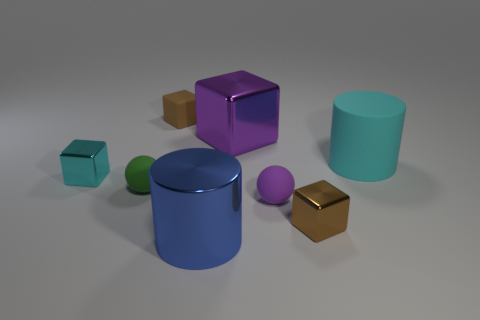There is a metal object that is the same color as the big matte cylinder; what is its shape?
Your answer should be compact. Cube. What number of small purple balls have the same material as the small green object?
Provide a succinct answer. 1. The big metallic cylinder has what color?
Offer a terse response. Blue. There is another ball that is the same size as the green matte ball; what color is it?
Keep it short and to the point. Purple. Is there a metal cube that has the same color as the rubber block?
Offer a very short reply. Yes. There is a tiny rubber object that is on the right side of the blue metal thing; is it the same shape as the green rubber thing on the left side of the large purple cube?
Ensure brevity in your answer.  Yes. What number of other things are the same size as the blue metal cylinder?
Keep it short and to the point. 2. Is the color of the small rubber cube the same as the metallic cube in front of the purple rubber object?
Offer a terse response. Yes. Is the number of purple matte objects that are right of the cyan rubber cylinder less than the number of small cubes on the left side of the blue object?
Offer a very short reply. Yes. What color is the metallic object that is behind the small purple rubber ball and on the left side of the large purple object?
Make the answer very short. Cyan. 